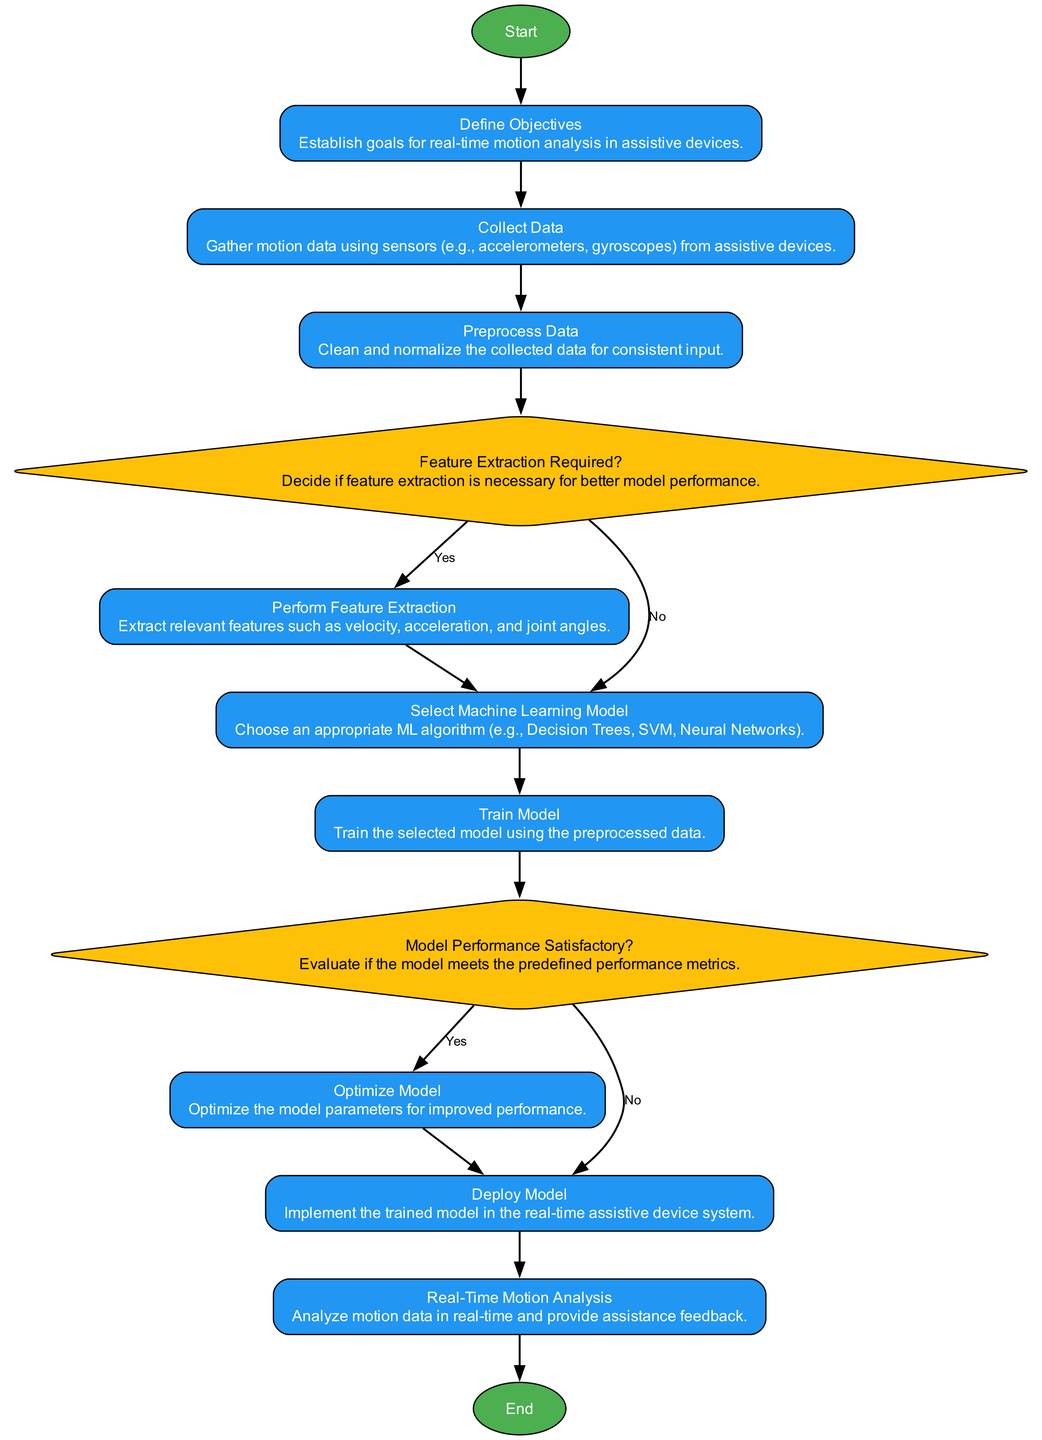What is the first step in the process? The first step in the process is labeled as "Start" which indicates the initiation of the flowchart.
Answer: Start How many decision nodes are present in the diagram? There are two decision nodes in the diagram: one for "Feature Extraction Required?" and another for "Model Performance Satisfactory?"
Answer: 2 Which process follows the "Collect Data" step? The process that follows "Collect Data" is "Preprocess Data" which is the next step in the sequence.
Answer: Preprocess Data What happens if the model performance is deemed satisfactory? If the model performance is satisfactory, the flow continues to "Deploy Model" where the trained model is implemented in the system.
Answer: Deploy Model What is the last step in the instruction flow? The last step in the instruction flow is labeled as "End," which signifies the conclusion of the process.
Answer: End What are the required actions if feature extraction is deemed necessary? If feature extraction is needed, the next action is to "Perform Feature Extraction" where relevant features such as velocity and acceleration are extracted.
Answer: Perform Feature Extraction How many total nodes are in the diagram? The total number of nodes in the diagram is thirteen, including the start and end nodes.
Answer: 13 Which process directly precedes "Real-Time Motion Analysis"? The process that directly precedes "Real-Time Motion Analysis" is "Deploy Model," indicating the implementation of the trained model before real-time analysis starts.
Answer: Deploy Model 